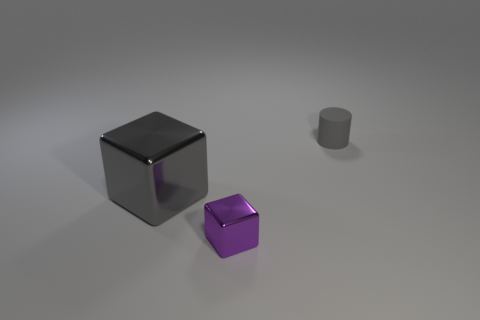Add 2 purple blocks. How many objects exist? 5 Subtract all cylinders. How many objects are left? 2 Add 2 small cylinders. How many small cylinders are left? 3 Add 3 gray matte things. How many gray matte things exist? 4 Subtract 0 gray balls. How many objects are left? 3 Subtract all cylinders. Subtract all shiny blocks. How many objects are left? 0 